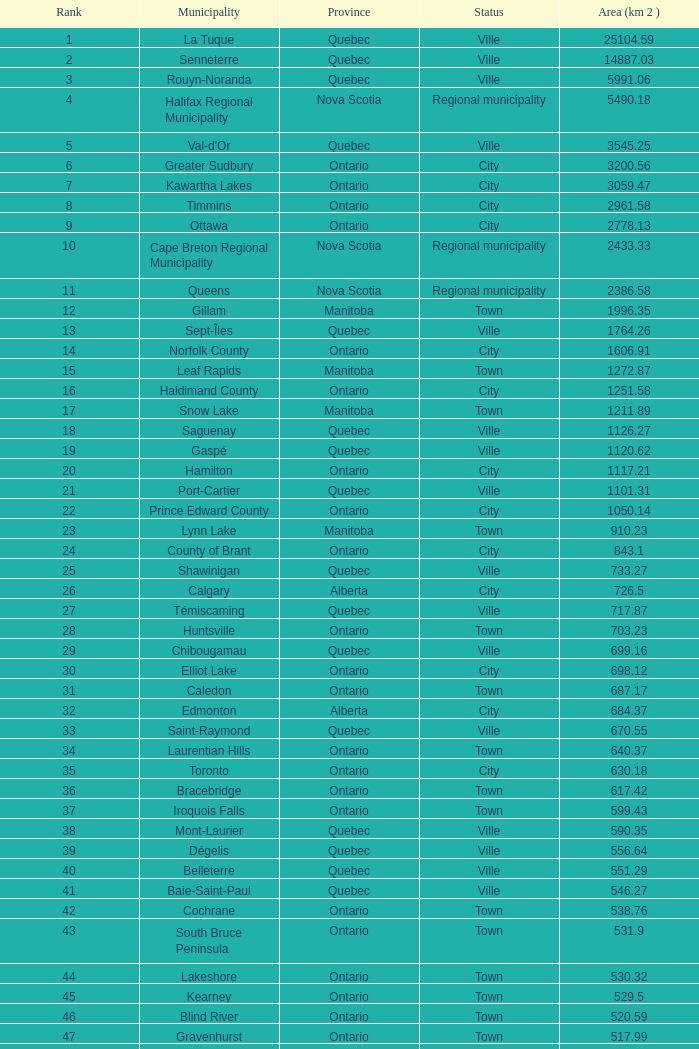What's the overall rank having an area (km 2) of 105 22.0. 